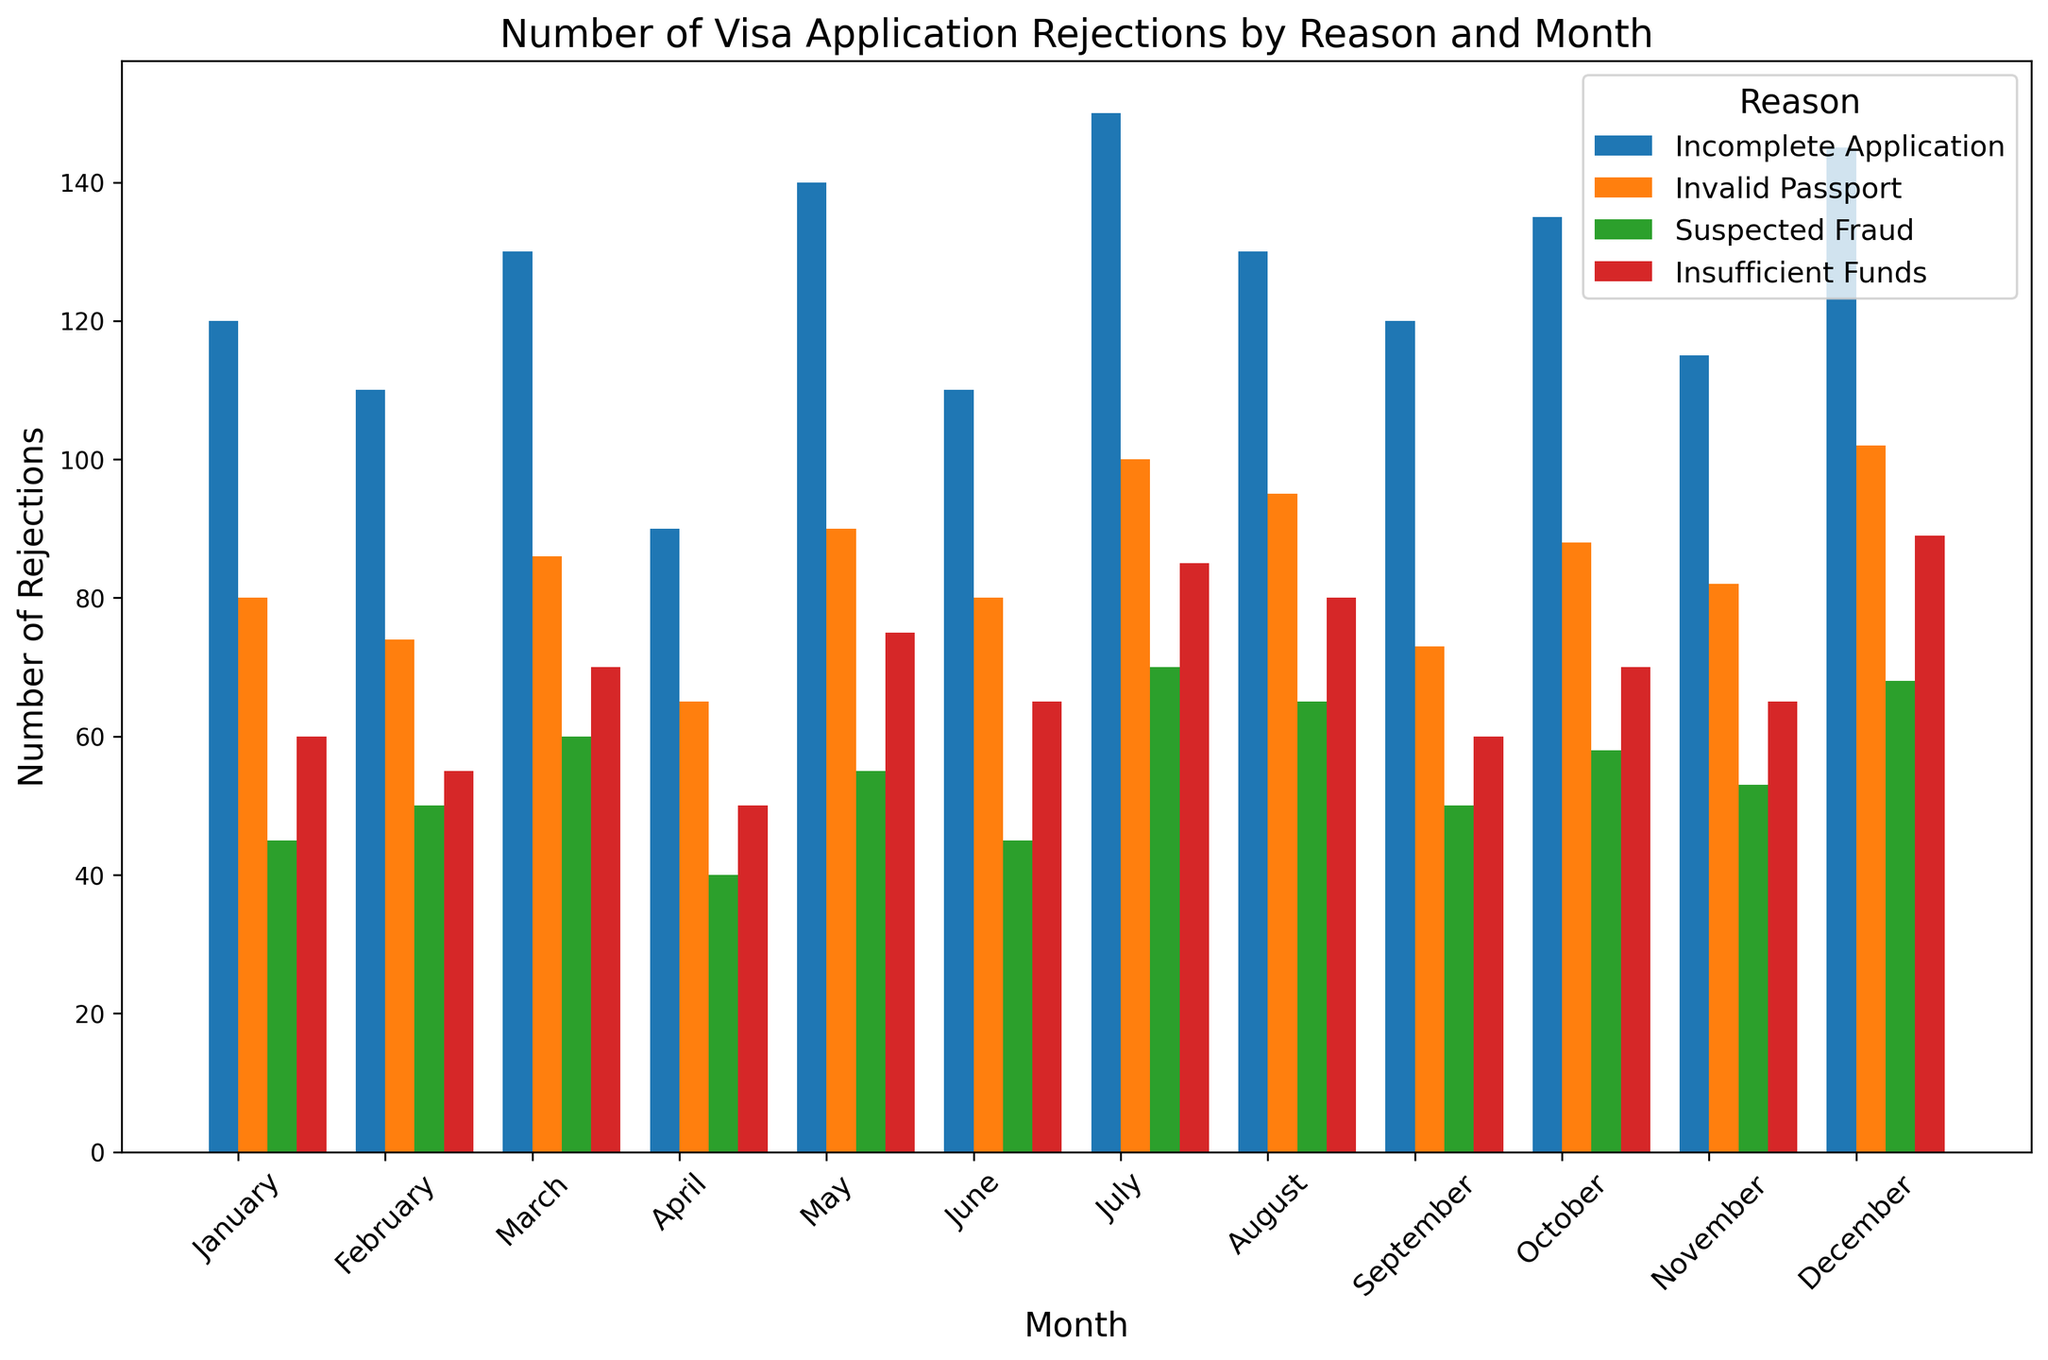Which month had the highest total number of rejections? Sum up the number of rejections for each month across all reasons. The month of July has the highest total rejections: 150 (Incomplete Application) + 100 (Invalid Passport) + 70 (Suspected Fraud) + 85 (Insufficient Funds) = 405.
Answer: July What is the difference in rejections due to 'Invalid Passport' between August and January? The number of rejections for 'Invalid Passport' in August is 95 and in January is 80. The difference is 95 - 80 = 15.
Answer: 15 In which month were 'Suspected Fraud' rejections the lowest? Look for the month with the lowest bar height for 'Suspected Fraud'. The month with the lowest rejections (40) for 'Suspected Fraud' is April.
Answer: April How many more rejections were there for 'Incomplete Application' compared to 'Insufficient Funds' in December? The number of rejections for 'Incomplete Application' in December is 145, and for 'Insufficient Funds' is 89. The difference is 145 - 89 = 56.
Answer: 56 Which reason had the most rejections in January? Identify the tallest bar for January. The tallest bar corresponds to 'Incomplete Application' with 120 rejections.
Answer: Incomplete Application What is the average number of rejections due to 'Suspected Fraud' over the year? Sum the monthly rejections for 'Suspected Fraud' and divide by the number of months (12): (45 + 50 + 60 + 40 + 55 + 45 + 70 + 65 + 50 + 58 + 53 + 68) / 12 = 56.
Answer: 56 Are there more 'Invalid Passport' rejections in the first half (January-June) or the second half (July-December) of the year? Sum 'Invalid Passport' rejections from January to June: 80 + 74 + 86 + 65 + 90 + 80 = 475. Sum from July to December: 100 + 95 + 73 + 88 + 82 + 102 = 540. The second half of the year has more rejections (540 vs 475).
Answer: Second half Which reason saw an increase in rejections from February to March? Compare the number of rejections from February to March for each reason: 'Incomplete Application' (110 to 130), 'Invalid Passport' (74 to 86), 'Suspected Fraud' (50 to 60), 'Insufficient Funds' (55 to 70). All reasons show an increase.
Answer: All reasons What is the total number of rejections in April? Sum the rejections for April across all reasons: 90 (Incomplete Application) + 65 (Invalid Passport) + 40 (Suspected Fraud) + 50 (Insufficient Funds) = 245.
Answer: 245 Which month experienced the highest number of rejections for 'Incomplete Application'? Identify the month with the highest bar for 'Incomplete Application'. The month of July has the highest rejections (150) for 'Incomplete Application'.
Answer: July 